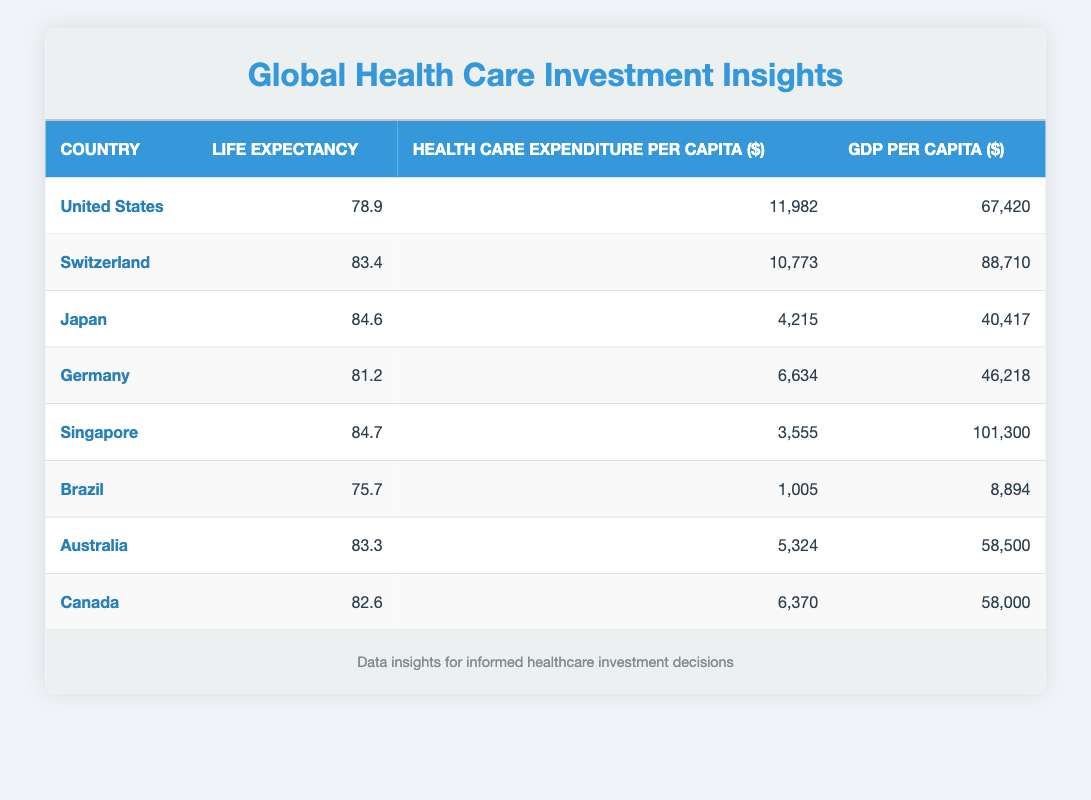What is the life expectancy in Japan? The life expectancy in Japan can be found directly in the table, where it shows 84.6 years as the value for Japan.
Answer: 84.6 Which country has the highest health care expenditure per capita? By examining the health care expenditure per capita column, the highest value is recorded under the United States at 11,982 dollars.
Answer: United States What is the average life expectancy of the countries listed? To find the average, add the life expectancies: 78.9 + 83.4 + 84.6 + 81.2 + 84.7 + 75.7 + 83.3 + 82.6 = 674.4. Then, divide by the number of countries, which is 8: 674.4 / 8 = 84.3.
Answer: 84.3 Is the life expectancy higher in Canada or Germany? The life expectancy for Canada is 82.6 years, and for Germany, it is 81.2 years. Since 82.6 is greater than 81.2, Canada has the higher life expectancy.
Answer: Yes Which country has a life expectancy of 75.7 years, and what is its health care expenditure per capita? Brazil has a life expectancy of 75.7 years, and its health care expenditure per capita is 1,005 dollars, as shown in the respective row for Brazil in the table.
Answer: Brazil, 1,005 What is the difference in health care expenditure per capita between Switzerland and Singapore? Switzerland has a health care expenditure of 10,773 dollars while Singapore has 3,555 dollars. To find the difference: 10,773 - 3,555 = 7,218.
Answer: 7,218 Are there any countries that have a life expectancy above 83 years and a GDP per capita over 80,000 dollars? By checking the life expectancy and GDP per capita columns, Switzerland (83.4 years, 88,710 dollars) and Singapore (84.7 years, 101,300 dollars) meet both criteria.
Answer: Yes What is the relationship between health care expenditure and life expectancy for Japan? Japan has low health care expenditure per capita at 4,215 dollars paired with a high life expectancy of 84.6 years. This suggests that high life expectancy can be achieved even with relatively low expenditures.
Answer: High life expectancy with low expenditure 